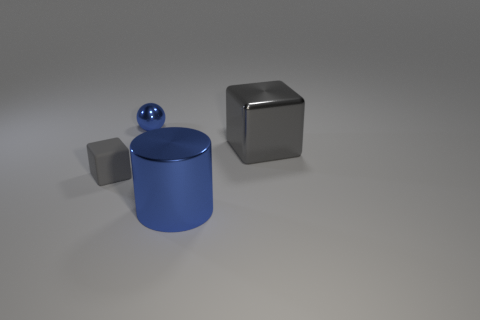What number of cyan blocks have the same material as the big cylinder?
Your response must be concise. 0. What number of metallic cubes have the same color as the tiny metal thing?
Make the answer very short. 0. What number of objects are gray blocks right of the tiny gray matte block or blue metal things that are in front of the rubber object?
Make the answer very short. 2. Is the number of blue metallic cylinders that are behind the blue shiny ball less than the number of shiny spheres?
Make the answer very short. Yes. Is there a matte object of the same size as the gray matte cube?
Offer a very short reply. No. The big metallic block has what color?
Give a very brief answer. Gray. Does the blue shiny cylinder have the same size as the ball?
Make the answer very short. No. What number of objects are either shiny blocks or large things?
Offer a very short reply. 2. Is the number of large gray metal blocks that are in front of the tiny rubber thing the same as the number of tiny gray matte things?
Make the answer very short. No. Are there any large gray shiny blocks to the left of the gray thing that is left of the object on the right side of the big blue cylinder?
Keep it short and to the point. No. 